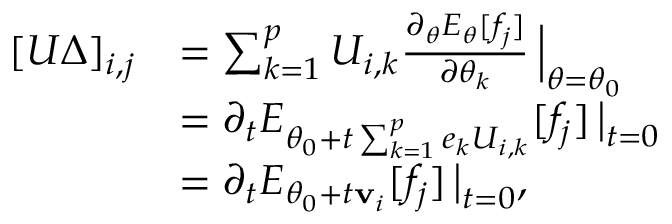<formula> <loc_0><loc_0><loc_500><loc_500>\begin{array} { r l } { [ U \Delta ] _ { i , j } } & { = \sum _ { k = 1 } ^ { p } U _ { i , k } \frac { \partial _ { \theta } E _ { \theta } [ f _ { j } ] } { \partial \theta _ { k } } \, \Big | _ { \theta = \theta _ { 0 } } } \\ & { = \partial _ { t } E _ { \theta _ { 0 } + t \sum _ { k = 1 } ^ { p } e _ { k } U _ { i , k } } [ f _ { j } ] \, \Big | _ { t = 0 } } \\ & { = \partial _ { t } E _ { \theta _ { 0 } + t { v } _ { i } } [ f _ { j } ] \, \Big | _ { t = 0 } , } \end{array}</formula> 